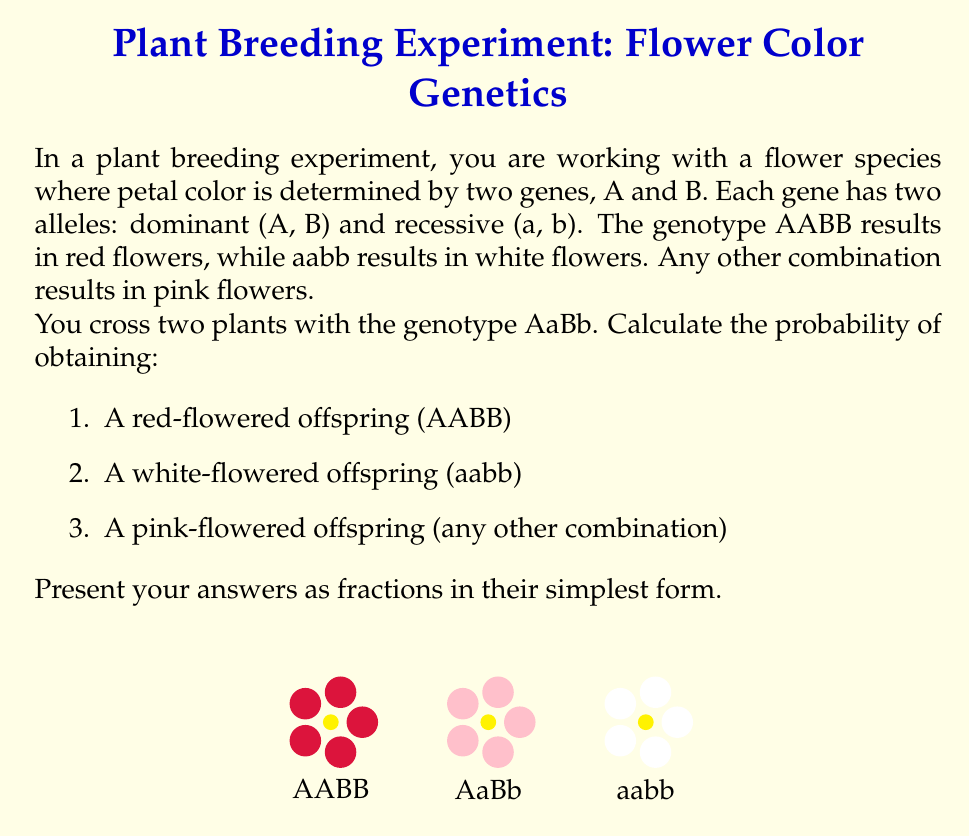Help me with this question. Let's approach this step-by-step:

1) First, we need to determine the possible gametes from each parent. With genotype AaBb, each parent can produce four types of gametes: AB, Ab, aB, and ab.

2) We can use a Punnett square to visualize all possible combinations:

   $$\begin{array}{c|c|c|c|c}
     & AB & Ab & aB & ab \\
   \hline
   AB & AABB & AABb & AaBB & AaBb \\
   \hline
   Ab & AABb & AAbb & AaBb & Aabb \\
   \hline
   aB & AaBB & AaBb & aaBB & aaBb \\
   \hline
   ab & AaBb & Aabb & aaBb & aabb
   \end{array}$$

3) Now, let's count the occurrences of each phenotype:

   Red (AABB): 1 out of 16
   White (aabb): 1 out of 16
   Pink (all others): 14 out of 16

4) To calculate the probabilities:

   Red: $P(AABB) = \frac{1}{16}$
   White: $P(aabb) = \frac{1}{16}$
   Pink: $P(\text{pink}) = \frac{14}{16} = \frac{7}{8}$

These fractions are already in their simplest form.
Answer: 1) $\frac{1}{16}$
2) $\frac{1}{16}$
3) $\frac{7}{8}$ 